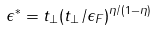Convert formula to latex. <formula><loc_0><loc_0><loc_500><loc_500>\epsilon ^ { * } = t _ { \perp } ( t _ { \perp } / \epsilon _ { F } ) ^ { \eta / ( 1 - \eta ) }</formula> 